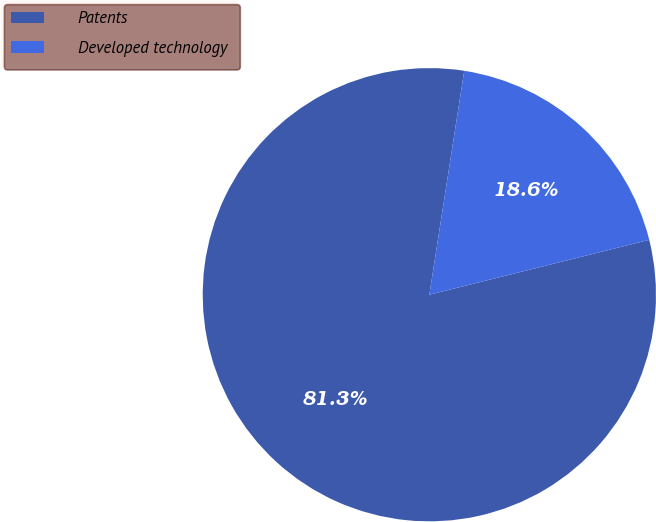Convert chart. <chart><loc_0><loc_0><loc_500><loc_500><pie_chart><fcel>Patents<fcel>Developed technology<nl><fcel>81.35%<fcel>18.65%<nl></chart> 